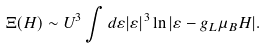<formula> <loc_0><loc_0><loc_500><loc_500>\Xi ( H ) \sim U ^ { 3 } \int d \varepsilon | \varepsilon | ^ { 3 } \ln | \varepsilon - g _ { L } \mu _ { B } H | .</formula> 